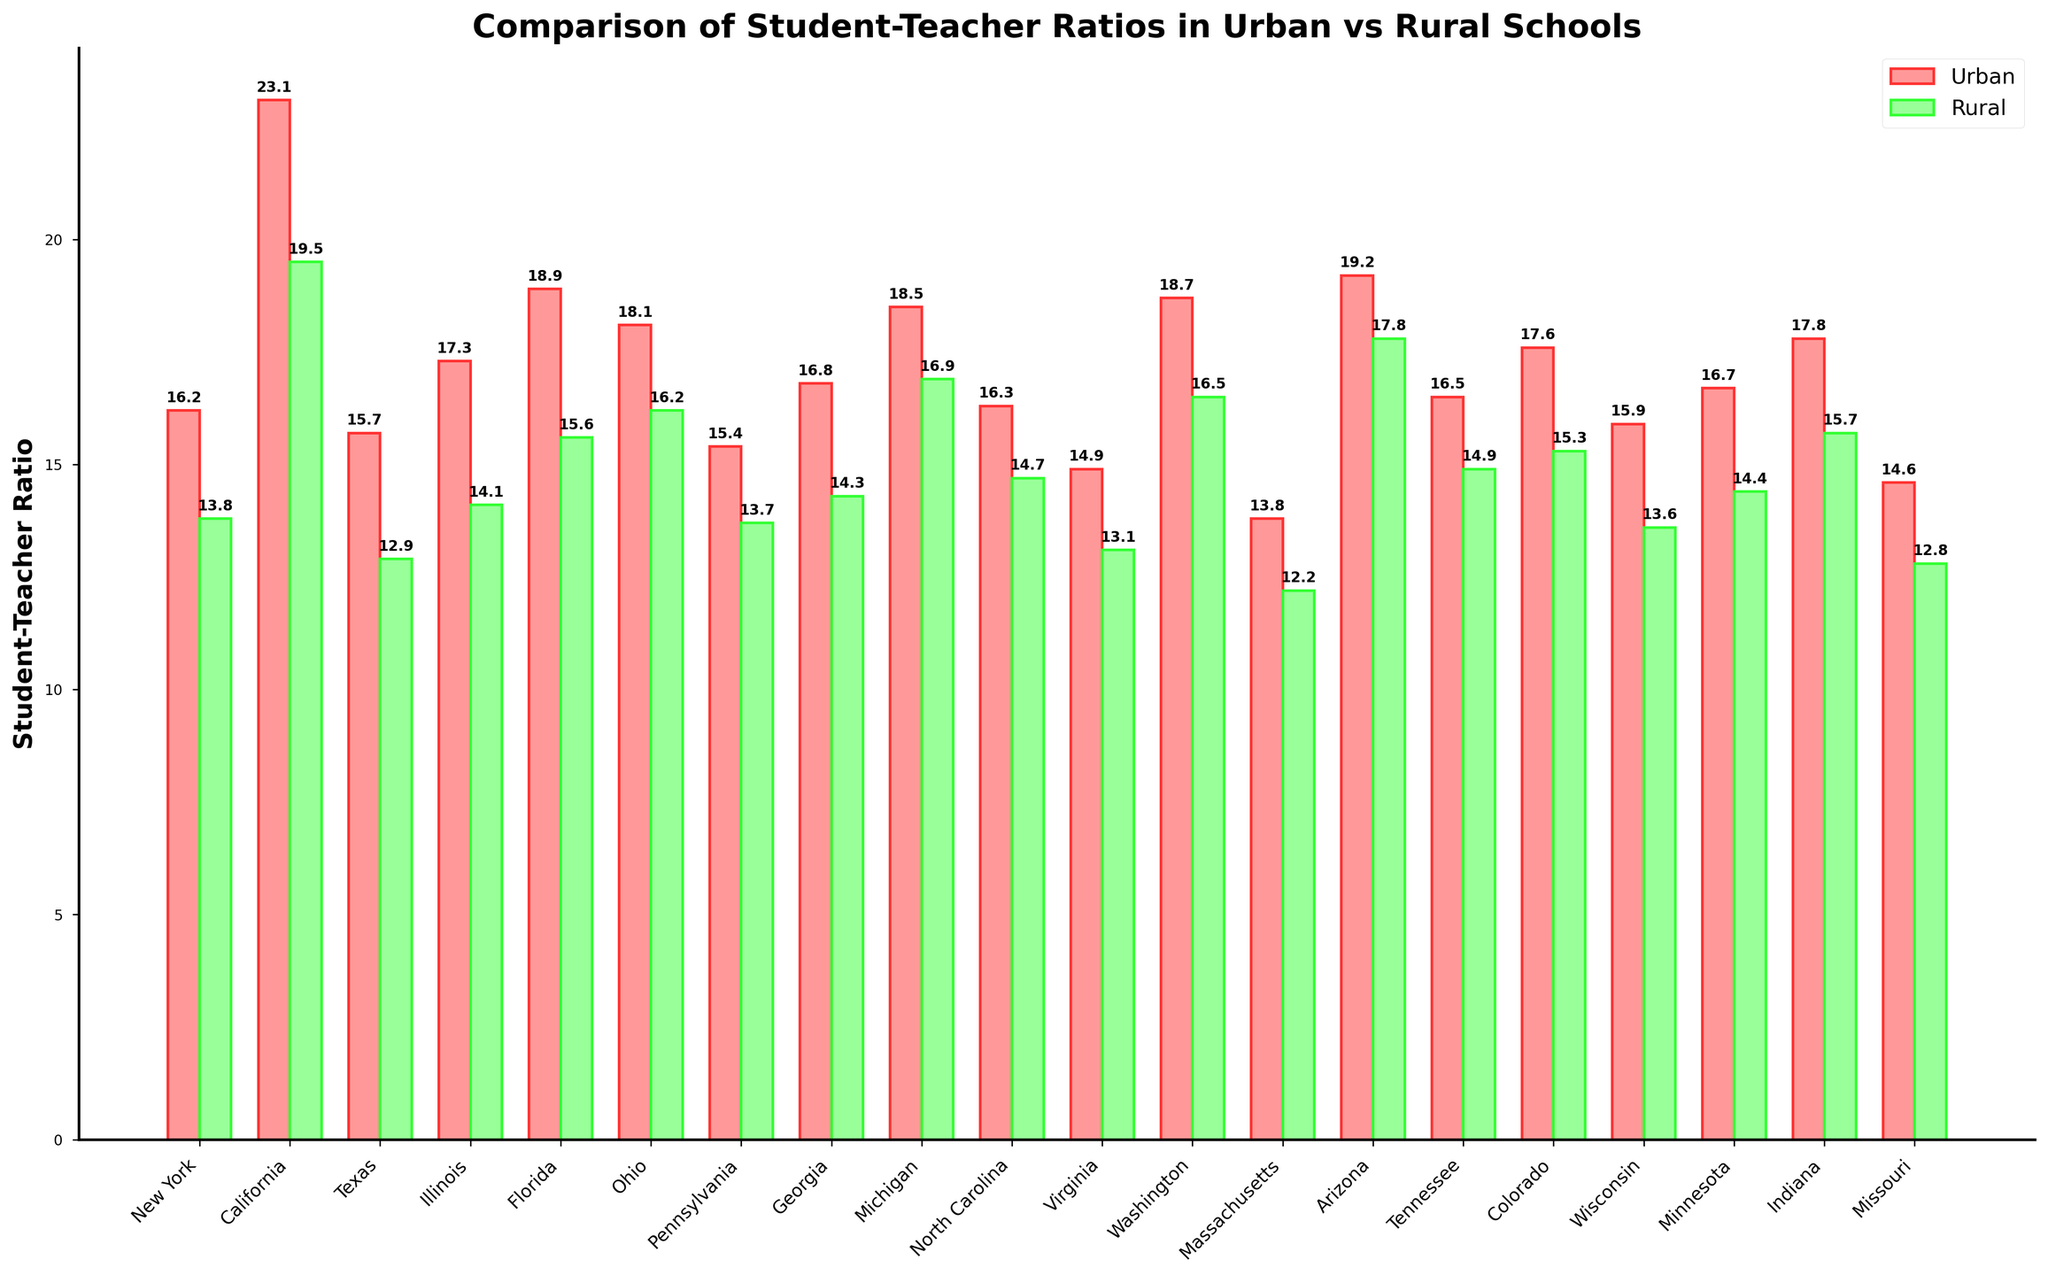what is the difference between the Urban and Rural ratios for California? Look at the bar heights for Urban and Rural in California. Subtract the Rural ratio (19.5) from the Urban ratio (23.1) to find the difference.
Answer: 3.6 Which state has the highest Urban student-teacher ratio? Compare the heights of the Urban bars across all states.
Answer: California Which state shows the smallest difference between Urban and Rural student-teacher ratios? Calculate the difference between the Urban and Rural ratios for all states, then find the state with the smallest difference.
Answer: Massachusetts On average, do Urban or Rural schools tend to have higher student-teacher ratios across the states shown? Compare the average heights of the Urban and Rural bars. Calculate the average for each type and compare them.
Answer: Urban Considering both Urban and Rural ratios, which state has the highest combined student-teacher ratio? Add both Urban and Rural ratios for each state and find the state with the highest total.
Answer: California Which state has a Rural student-teacher ratio closest to the national average for Urban schools? Calculate the average Urban ratio across all states. Find the Rural ratio closest to this value.
Answer: Tennessee (14.3 is closest to 16.5, the average Urban ratio) Are there any states where the Urban student-teacher ratio is less than the Rural student-teacher ratio? Compare Urban and Rural ratios within each state to check if Urban is ever less than Rural.
Answer: No What is the combined student-teacher ratio (sum of Urban and Rural) for Illinois? Add Urban (17.3) and Rural (14.1) ratios for Illinois.
Answer: 31.4 In which state is the disparity between Urban and Rural student-teacher ratios the greatest? Find the state with the largest difference between Urban and Rural ratios.
Answer: California 